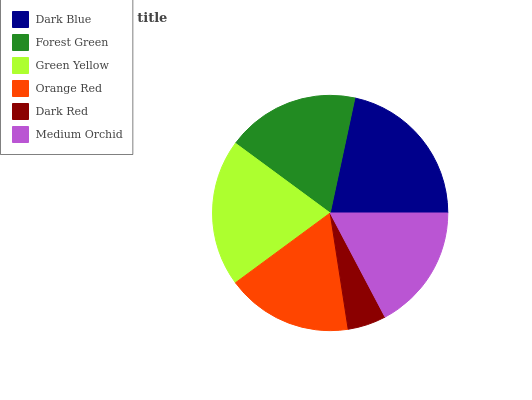Is Dark Red the minimum?
Answer yes or no. Yes. Is Dark Blue the maximum?
Answer yes or no. Yes. Is Forest Green the minimum?
Answer yes or no. No. Is Forest Green the maximum?
Answer yes or no. No. Is Dark Blue greater than Forest Green?
Answer yes or no. Yes. Is Forest Green less than Dark Blue?
Answer yes or no. Yes. Is Forest Green greater than Dark Blue?
Answer yes or no. No. Is Dark Blue less than Forest Green?
Answer yes or no. No. Is Forest Green the high median?
Answer yes or no. Yes. Is Orange Red the low median?
Answer yes or no. Yes. Is Orange Red the high median?
Answer yes or no. No. Is Green Yellow the low median?
Answer yes or no. No. 